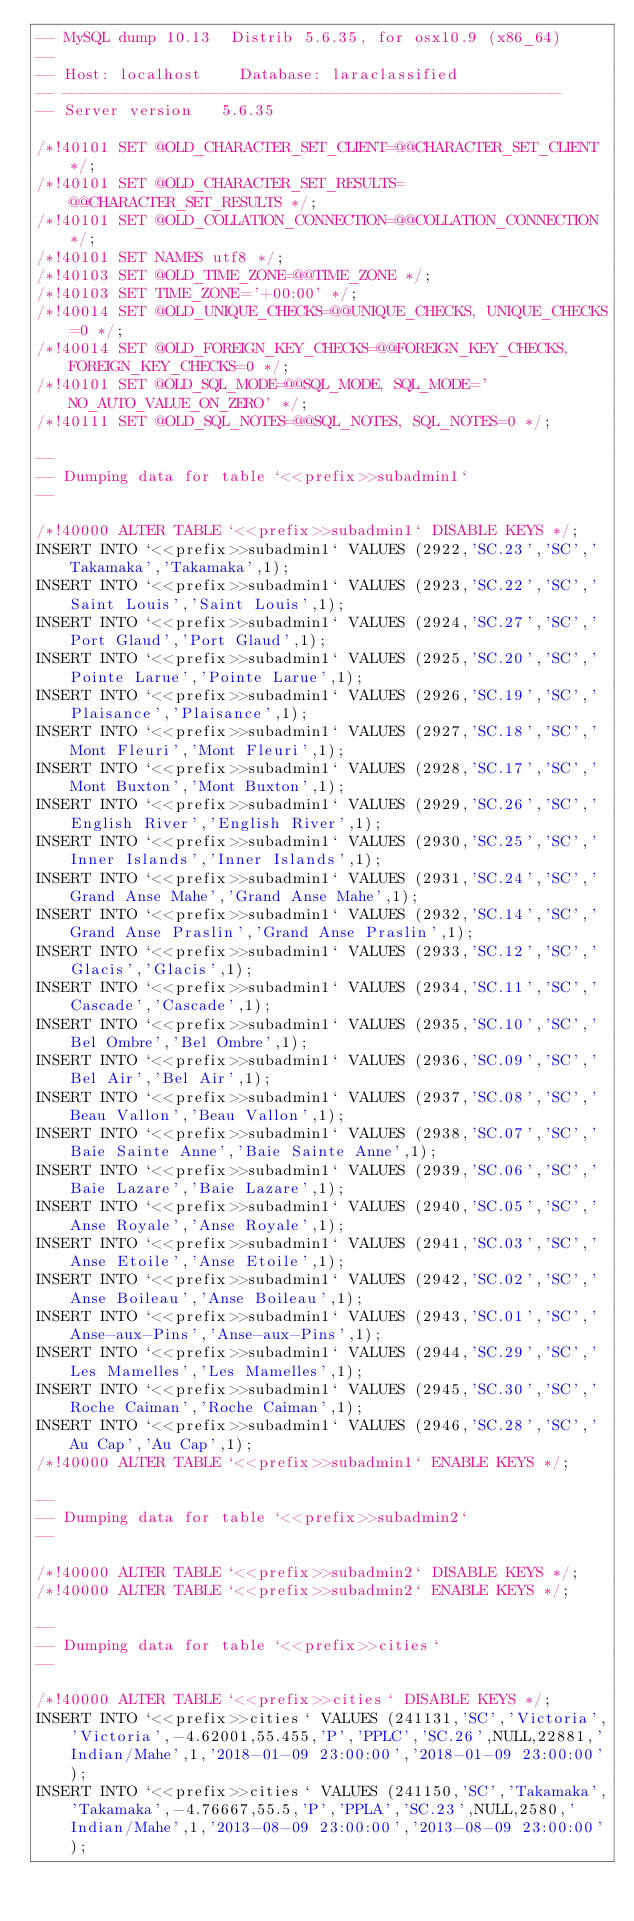<code> <loc_0><loc_0><loc_500><loc_500><_SQL_>-- MySQL dump 10.13  Distrib 5.6.35, for osx10.9 (x86_64)
--
-- Host: localhost    Database: laraclassified
-- ------------------------------------------------------
-- Server version	5.6.35

/*!40101 SET @OLD_CHARACTER_SET_CLIENT=@@CHARACTER_SET_CLIENT */;
/*!40101 SET @OLD_CHARACTER_SET_RESULTS=@@CHARACTER_SET_RESULTS */;
/*!40101 SET @OLD_COLLATION_CONNECTION=@@COLLATION_CONNECTION */;
/*!40101 SET NAMES utf8 */;
/*!40103 SET @OLD_TIME_ZONE=@@TIME_ZONE */;
/*!40103 SET TIME_ZONE='+00:00' */;
/*!40014 SET @OLD_UNIQUE_CHECKS=@@UNIQUE_CHECKS, UNIQUE_CHECKS=0 */;
/*!40014 SET @OLD_FOREIGN_KEY_CHECKS=@@FOREIGN_KEY_CHECKS, FOREIGN_KEY_CHECKS=0 */;
/*!40101 SET @OLD_SQL_MODE=@@SQL_MODE, SQL_MODE='NO_AUTO_VALUE_ON_ZERO' */;
/*!40111 SET @OLD_SQL_NOTES=@@SQL_NOTES, SQL_NOTES=0 */;

--
-- Dumping data for table `<<prefix>>subadmin1`
--

/*!40000 ALTER TABLE `<<prefix>>subadmin1` DISABLE KEYS */;
INSERT INTO `<<prefix>>subadmin1` VALUES (2922,'SC.23','SC','Takamaka','Takamaka',1);
INSERT INTO `<<prefix>>subadmin1` VALUES (2923,'SC.22','SC','Saint Louis','Saint Louis',1);
INSERT INTO `<<prefix>>subadmin1` VALUES (2924,'SC.27','SC','Port Glaud','Port Glaud',1);
INSERT INTO `<<prefix>>subadmin1` VALUES (2925,'SC.20','SC','Pointe Larue','Pointe Larue',1);
INSERT INTO `<<prefix>>subadmin1` VALUES (2926,'SC.19','SC','Plaisance','Plaisance',1);
INSERT INTO `<<prefix>>subadmin1` VALUES (2927,'SC.18','SC','Mont Fleuri','Mont Fleuri',1);
INSERT INTO `<<prefix>>subadmin1` VALUES (2928,'SC.17','SC','Mont Buxton','Mont Buxton',1);
INSERT INTO `<<prefix>>subadmin1` VALUES (2929,'SC.26','SC','English River','English River',1);
INSERT INTO `<<prefix>>subadmin1` VALUES (2930,'SC.25','SC','Inner Islands','Inner Islands',1);
INSERT INTO `<<prefix>>subadmin1` VALUES (2931,'SC.24','SC','Grand Anse Mahe','Grand Anse Mahe',1);
INSERT INTO `<<prefix>>subadmin1` VALUES (2932,'SC.14','SC','Grand Anse Praslin','Grand Anse Praslin',1);
INSERT INTO `<<prefix>>subadmin1` VALUES (2933,'SC.12','SC','Glacis','Glacis',1);
INSERT INTO `<<prefix>>subadmin1` VALUES (2934,'SC.11','SC','Cascade','Cascade',1);
INSERT INTO `<<prefix>>subadmin1` VALUES (2935,'SC.10','SC','Bel Ombre','Bel Ombre',1);
INSERT INTO `<<prefix>>subadmin1` VALUES (2936,'SC.09','SC','Bel Air','Bel Air',1);
INSERT INTO `<<prefix>>subadmin1` VALUES (2937,'SC.08','SC','Beau Vallon','Beau Vallon',1);
INSERT INTO `<<prefix>>subadmin1` VALUES (2938,'SC.07','SC','Baie Sainte Anne','Baie Sainte Anne',1);
INSERT INTO `<<prefix>>subadmin1` VALUES (2939,'SC.06','SC','Baie Lazare','Baie Lazare',1);
INSERT INTO `<<prefix>>subadmin1` VALUES (2940,'SC.05','SC','Anse Royale','Anse Royale',1);
INSERT INTO `<<prefix>>subadmin1` VALUES (2941,'SC.03','SC','Anse Etoile','Anse Etoile',1);
INSERT INTO `<<prefix>>subadmin1` VALUES (2942,'SC.02','SC','Anse Boileau','Anse Boileau',1);
INSERT INTO `<<prefix>>subadmin1` VALUES (2943,'SC.01','SC','Anse-aux-Pins','Anse-aux-Pins',1);
INSERT INTO `<<prefix>>subadmin1` VALUES (2944,'SC.29','SC','Les Mamelles','Les Mamelles',1);
INSERT INTO `<<prefix>>subadmin1` VALUES (2945,'SC.30','SC','Roche Caiman','Roche Caiman',1);
INSERT INTO `<<prefix>>subadmin1` VALUES (2946,'SC.28','SC','Au Cap','Au Cap',1);
/*!40000 ALTER TABLE `<<prefix>>subadmin1` ENABLE KEYS */;

--
-- Dumping data for table `<<prefix>>subadmin2`
--

/*!40000 ALTER TABLE `<<prefix>>subadmin2` DISABLE KEYS */;
/*!40000 ALTER TABLE `<<prefix>>subadmin2` ENABLE KEYS */;

--
-- Dumping data for table `<<prefix>>cities`
--

/*!40000 ALTER TABLE `<<prefix>>cities` DISABLE KEYS */;
INSERT INTO `<<prefix>>cities` VALUES (241131,'SC','Victoria','Victoria',-4.62001,55.455,'P','PPLC','SC.26',NULL,22881,'Indian/Mahe',1,'2018-01-09 23:00:00','2018-01-09 23:00:00');
INSERT INTO `<<prefix>>cities` VALUES (241150,'SC','Takamaka','Takamaka',-4.76667,55.5,'P','PPLA','SC.23',NULL,2580,'Indian/Mahe',1,'2013-08-09 23:00:00','2013-08-09 23:00:00');</code> 